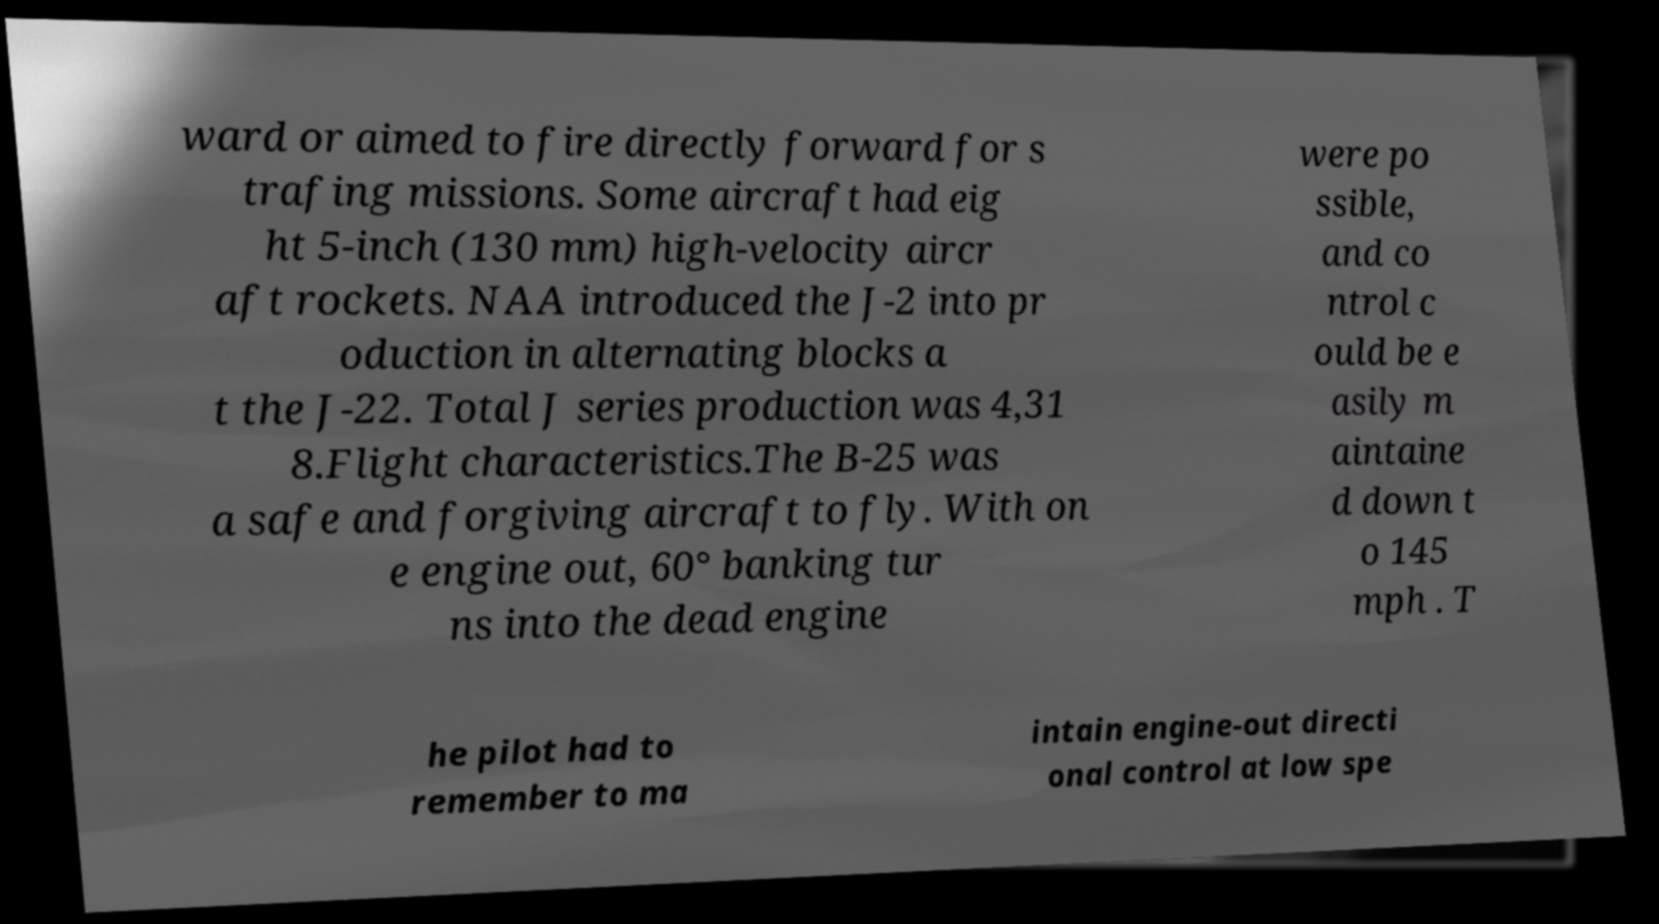Please identify and transcribe the text found in this image. ward or aimed to fire directly forward for s trafing missions. Some aircraft had eig ht 5-inch (130 mm) high-velocity aircr aft rockets. NAA introduced the J-2 into pr oduction in alternating blocks a t the J-22. Total J series production was 4,31 8.Flight characteristics.The B-25 was a safe and forgiving aircraft to fly. With on e engine out, 60° banking tur ns into the dead engine were po ssible, and co ntrol c ould be e asily m aintaine d down t o 145 mph . T he pilot had to remember to ma intain engine-out directi onal control at low spe 